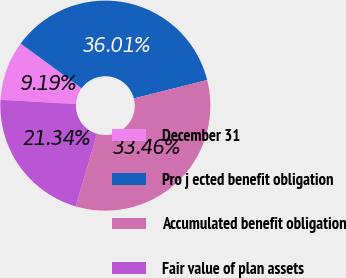Convert chart. <chart><loc_0><loc_0><loc_500><loc_500><pie_chart><fcel>December 31<fcel>Pro j ected benefit obligation<fcel>Accumulated benefit obligation<fcel>Fair value of plan assets<nl><fcel>9.19%<fcel>36.01%<fcel>33.46%<fcel>21.34%<nl></chart> 